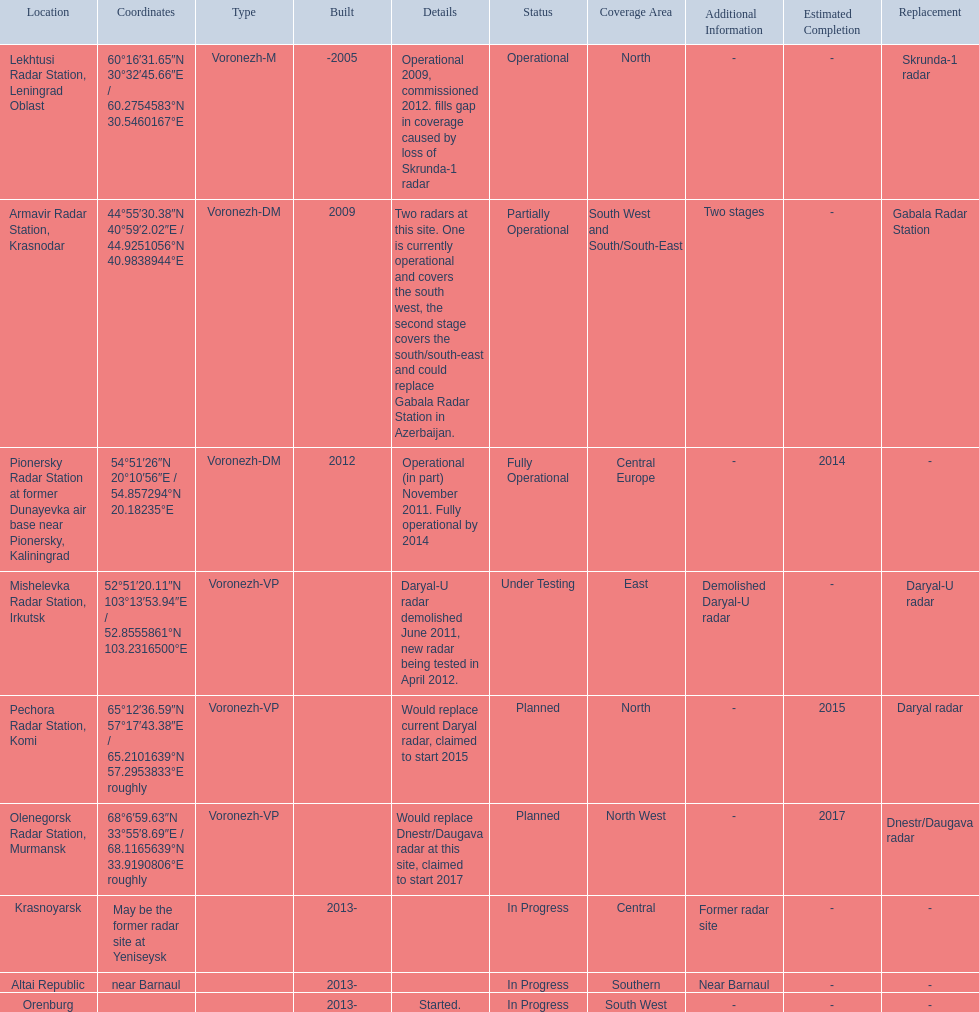Which column has the coordinates starting with 60 deg? 60°16′31.65″N 30°32′45.66″E﻿ / ﻿60.2754583°N 30.5460167°E. What is the location in the same row as that column? Lekhtusi Radar Station, Leningrad Oblast. 